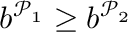Convert formula to latex. <formula><loc_0><loc_0><loc_500><loc_500>b ^ { \mathcal { P } _ { 1 } } \geq b ^ { \mathcal { P } _ { 2 } }</formula> 